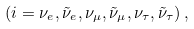Convert formula to latex. <formula><loc_0><loc_0><loc_500><loc_500>( i = \nu _ { e } , \tilde { \nu } _ { e } , \nu _ { \mu } , \tilde { \nu } _ { \mu } , \nu _ { \tau } , \tilde { \nu } _ { \tau } ) \, ,</formula> 